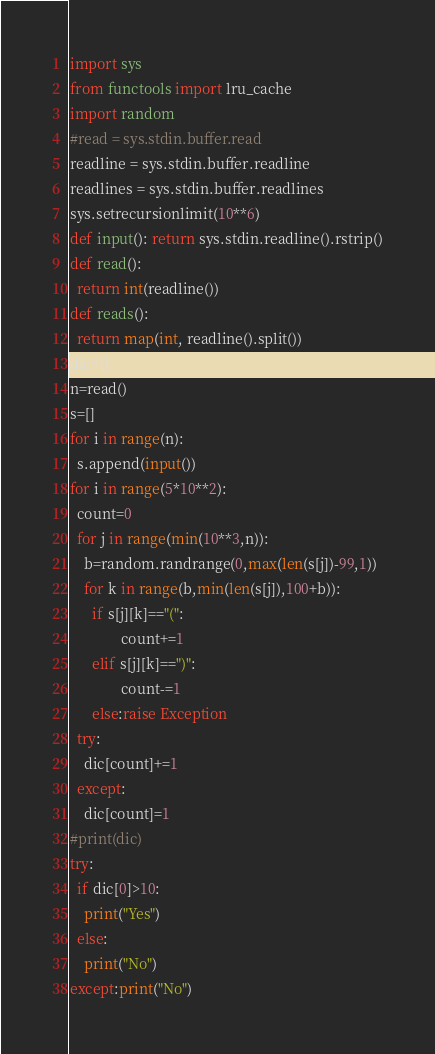<code> <loc_0><loc_0><loc_500><loc_500><_Python_>import sys
from functools import lru_cache
import random
#read = sys.stdin.buffer.read
readline = sys.stdin.buffer.readline
readlines = sys.stdin.buffer.readlines
sys.setrecursionlimit(10**6)
def input(): return sys.stdin.readline().rstrip()
def read():
  return int(readline())
def reads():
  return map(int, readline().split())
dic={}
n=read()
s=[]
for i in range(n):
  s.append(input())
for i in range(5*10**2):
  count=0
  for j in range(min(10**3,n)):
    b=random.randrange(0,max(len(s[j])-99,1))
    for k in range(b,min(len(s[j]),100+b)):
      if s[j][k]=="(":
              count+=1
      elif s[j][k]==")":
              count-=1
      else:raise Exception
  try:
    dic[count]+=1
  except:
    dic[count]=1
#print(dic)
try:
  if dic[0]>10:
    print("Yes")
  else:
    print("No")
except:print("No")</code> 